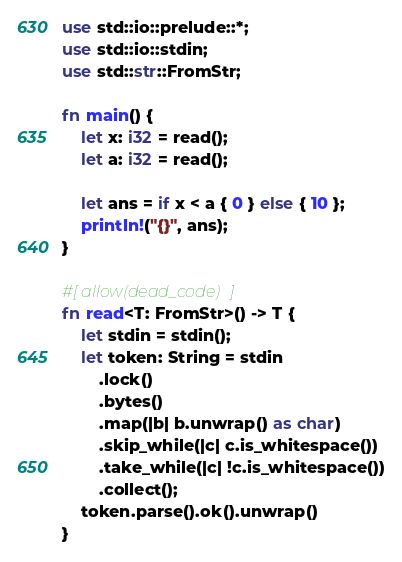<code> <loc_0><loc_0><loc_500><loc_500><_Rust_>use std::io::prelude::*;
use std::io::stdin;
use std::str::FromStr;

fn main() {
    let x: i32 = read();
    let a: i32 = read();

    let ans = if x < a { 0 } else { 10 };
    println!("{}", ans);
}

#[allow(dead_code)]
fn read<T: FromStr>() -> T {
    let stdin = stdin();
    let token: String = stdin
        .lock()
        .bytes()
        .map(|b| b.unwrap() as char)
        .skip_while(|c| c.is_whitespace())
        .take_while(|c| !c.is_whitespace())
        .collect();
    token.parse().ok().unwrap()
}
</code> 